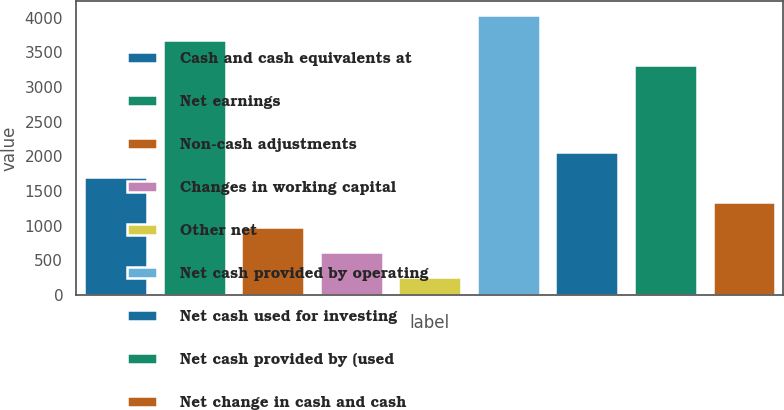<chart> <loc_0><loc_0><loc_500><loc_500><bar_chart><fcel>Cash and cash equivalents at<fcel>Net earnings<fcel>Non-cash adjustments<fcel>Changes in working capital<fcel>Other net<fcel>Net cash provided by operating<fcel>Net cash used for investing<fcel>Net cash provided by (used<fcel>Net change in cash and cash<nl><fcel>1697.6<fcel>3675.4<fcel>974.8<fcel>613.4<fcel>252<fcel>4036.8<fcel>2059<fcel>3314<fcel>1336.2<nl></chart> 